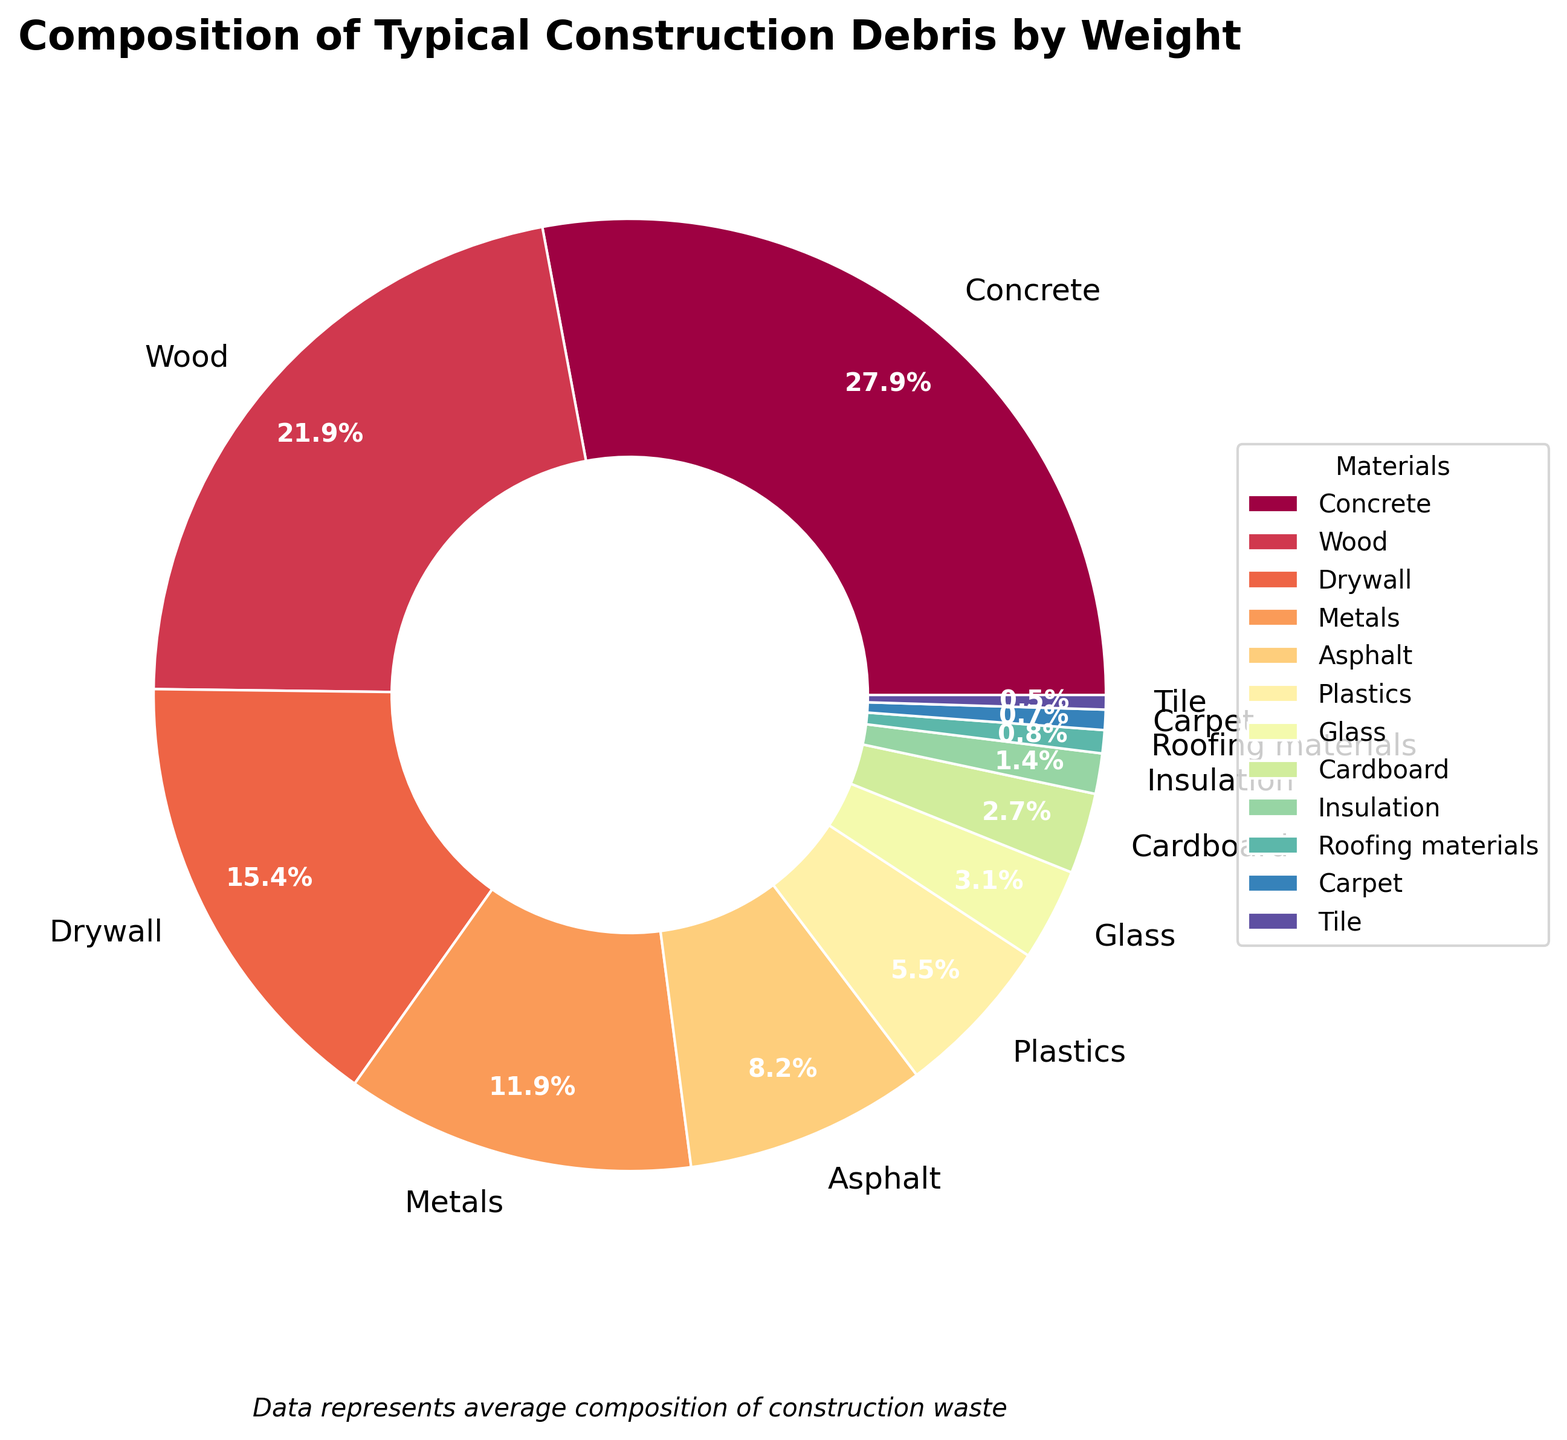what percentage of construction debris is composed of metals and cardboard combined? To find the combined percentage of metals and cardboard, add their individual percentages together: 12.1% (metals) + 2.8% (cardboard) = 14.9%.
Answer: 14.9% which material contributes more to construction debris, glass or plastics? Compare the percentages of glass and plastics in the pie chart. Glass has 3.2% and plastics have 5.6%. Since 5.6% is greater than 3.2%, plastics contribute more.
Answer: plastics does wood or asphalt have a larger percentage share in construction debris? Compare the percentages of wood and asphalt in the pie chart. Wood has 22.3% and asphalt has 8.4%. Since 22.3% is greater than 8.4%, wood has a larger share.
Answer: wood what is the total percentage of the three materials with the smallest contributions to construction debris? Identify the three smallest percentages: tile (0.5%), carpet (0.7%), and roofing materials (0.8%). Add these together: 0.5% + 0.7% + 0.8% = 2.0%.
Answer: 2.0% among concrete, wood, and drywall, which material has the highest percentage in construction debris? Compare the percentages of concrete, wood, and drywall. Concrete has 28.5%, wood has 22.3%, and drywall has 15.7%. Since 28.5% is the highest, concrete has the highest percentage.
Answer: concrete what visual attributes show that one material is significantly more common than most others? The size of the wedge in the pie chart and the percentage label. Concrete has the largest wedge and highest percentage (28.5%), visually indicating it is significantly more common than other materials.
Answer: concrete's wedge if you combined drywall and wood, would their total be greater than concrete alone? Add the percentages of drywall and wood: 15.7% (drywall) + 22.3% (wood) = 38%. Compare this to concrete's 28.5%. Since 38% is greater than 28.5%, the combination is greater.
Answer: yes how much more construction debris by percentage is contributed by concrete compared to carpet? Subtract the percentage of carpet from concrete: 28.5% (concrete) - 0.7% (carpet) = 27.8%.
Answer: 27.8% which materials collectively make up more than half of the construction debris? Sum the percentages from the largest downwards until reaching over 50%: 
Concrete (28.5%) + Wood (22.3%) = 50.8%. Concrete and wood together make up more than half.
Answer: concrete and wood if you were to allocate your leftover materials based on the chart, which materials would you most likely prioritize due to their large percentages? Look at the largest percentages in the chart: concrete (28.5%), wood (22.3%), and drywall (15.7%), as they are the largest contributors and should be prioritized for efficiency.
Answer: concrete, wood, and drywall 